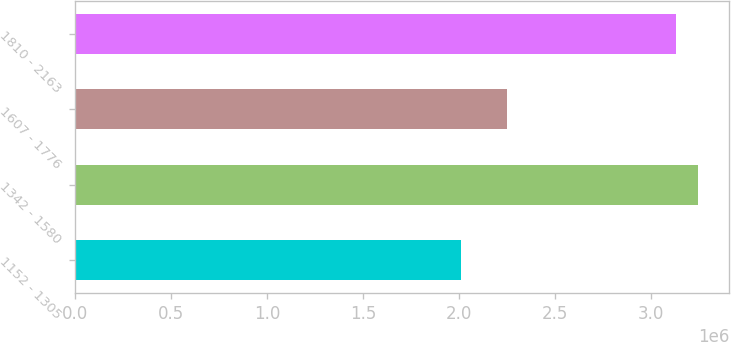<chart> <loc_0><loc_0><loc_500><loc_500><bar_chart><fcel>1152 - 1305<fcel>1342 - 1580<fcel>1607 - 1776<fcel>1810 - 2163<nl><fcel>2.01076e+06<fcel>3.2435e+06<fcel>2.25165e+06<fcel>3.12901e+06<nl></chart> 